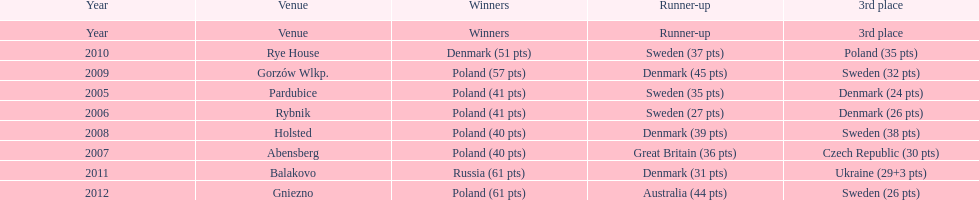What is the total number of points earned in the years 2009? 134. 